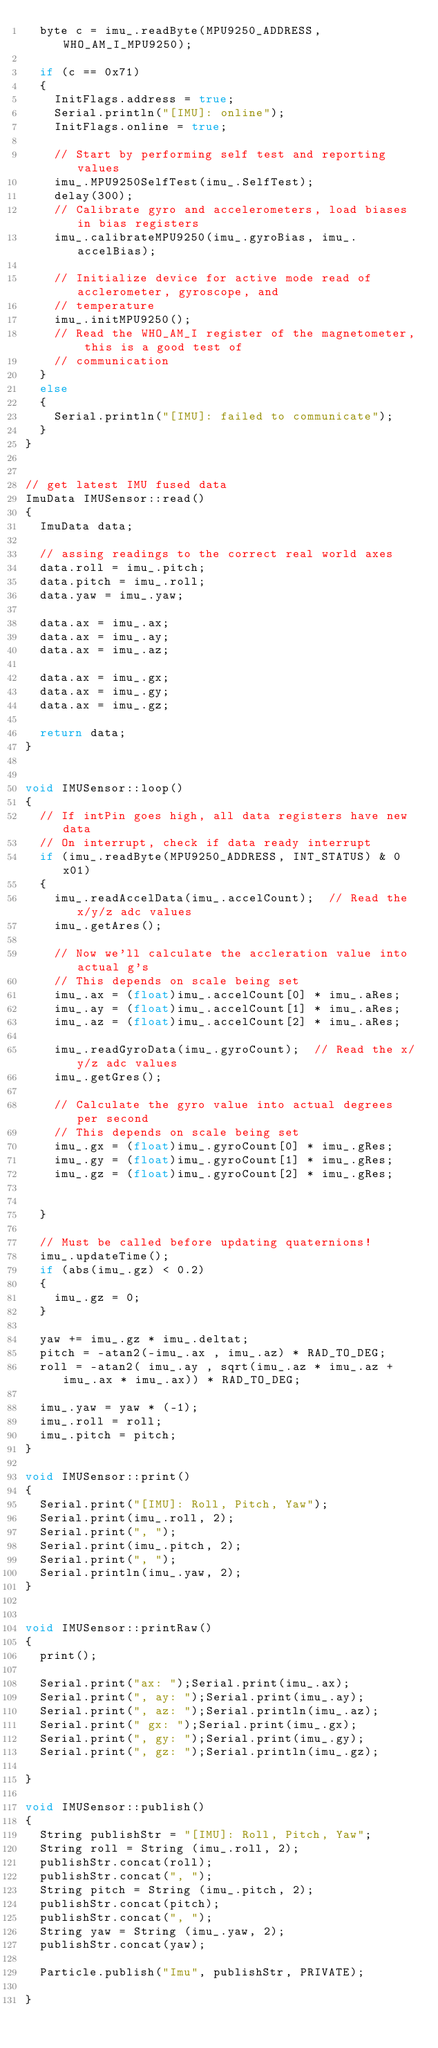Convert code to text. <code><loc_0><loc_0><loc_500><loc_500><_C++_>	byte c = imu_.readByte(MPU9250_ADDRESS, WHO_AM_I_MPU9250);

	if (c == 0x71)
	{
		InitFlags.address = true;
		Serial.println("[IMU]: online");
		InitFlags.online = true;

		// Start by performing self test and reporting values
		imu_.MPU9250SelfTest(imu_.SelfTest);
		delay(300);
		// Calibrate gyro and accelerometers, load biases in bias registers
		imu_.calibrateMPU9250(imu_.gyroBias, imu_.accelBias);

		// Initialize device for active mode read of acclerometer, gyroscope, and
		// temperature
		imu_.initMPU9250();
		// Read the WHO_AM_I register of the magnetometer, this is a good test of
		// communication
	}
	else
	{
		Serial.println("[IMU]: failed to communicate");
	}
}


// get latest IMU fused data
ImuData IMUSensor::read()
{
	ImuData data;

	// assing readings to the correct real world axes
	data.roll = imu_.pitch;
	data.pitch = imu_.roll;
	data.yaw = imu_.yaw;

	data.ax = imu_.ax;
	data.ax = imu_.ay;
	data.ax = imu_.az;

	data.ax = imu_.gx;
	data.ax = imu_.gy;
	data.ax = imu_.gz;

	return data;
}


void IMUSensor::loop()
{
	// If intPin goes high, all data registers have new data
	// On interrupt, check if data ready interrupt
	if (imu_.readByte(MPU9250_ADDRESS, INT_STATUS) & 0x01)
	{
		imu_.readAccelData(imu_.accelCount);  // Read the x/y/z adc values
		imu_.getAres();

		// Now we'll calculate the accleration value into actual g's
		// This depends on scale being set
		imu_.ax = (float)imu_.accelCount[0] * imu_.aRes;
		imu_.ay = (float)imu_.accelCount[1] * imu_.aRes;
		imu_.az = (float)imu_.accelCount[2] * imu_.aRes;

		imu_.readGyroData(imu_.gyroCount);  // Read the x/y/z adc values
		imu_.getGres();

		// Calculate the gyro value into actual degrees per second
		// This depends on scale being set
		imu_.gx = (float)imu_.gyroCount[0] * imu_.gRes;
		imu_.gy = (float)imu_.gyroCount[1] * imu_.gRes;
		imu_.gz = (float)imu_.gyroCount[2] * imu_.gRes;


	}

	// Must be called before updating quaternions!
	imu_.updateTime();
	if (abs(imu_.gz) < 0.2)
	{
		imu_.gz = 0;
	}

	yaw += imu_.gz * imu_.deltat;
	pitch = -atan2(-imu_.ax , imu_.az) * RAD_TO_DEG;
	roll = -atan2( imu_.ay , sqrt(imu_.az * imu_.az + imu_.ax * imu_.ax)) * RAD_TO_DEG;

	imu_.yaw = yaw * (-1);
	imu_.roll = roll;
	imu_.pitch = pitch;
}

void IMUSensor::print()
{
	Serial.print("[IMU]: Roll, Pitch, Yaw");
	Serial.print(imu_.roll, 2);
	Serial.print(", ");
	Serial.print(imu_.pitch, 2);
	Serial.print(", ");
	Serial.println(imu_.yaw, 2);
}


void IMUSensor::printRaw()
{
	print();

	Serial.print("ax: ");Serial.print(imu_.ax);
	Serial.print(", ay: ");Serial.print(imu_.ay);
	Serial.print(", az: ");Serial.println(imu_.az);
	Serial.print(" gx: ");Serial.print(imu_.gx);
	Serial.print(", gy: ");Serial.print(imu_.gy);
	Serial.print(", gz: ");Serial.println(imu_.gz);

}

void IMUSensor::publish()
{
	String publishStr = "[IMU]: Roll, Pitch, Yaw";
	String roll = String (imu_.roll, 2);
	publishStr.concat(roll);
	publishStr.concat(", ");
	String pitch = String (imu_.pitch, 2);
	publishStr.concat(pitch);
	publishStr.concat(", ");
	String yaw = String (imu_.yaw, 2);
	publishStr.concat(yaw);

	Particle.publish("Imu", publishStr, PRIVATE);

}
</code> 